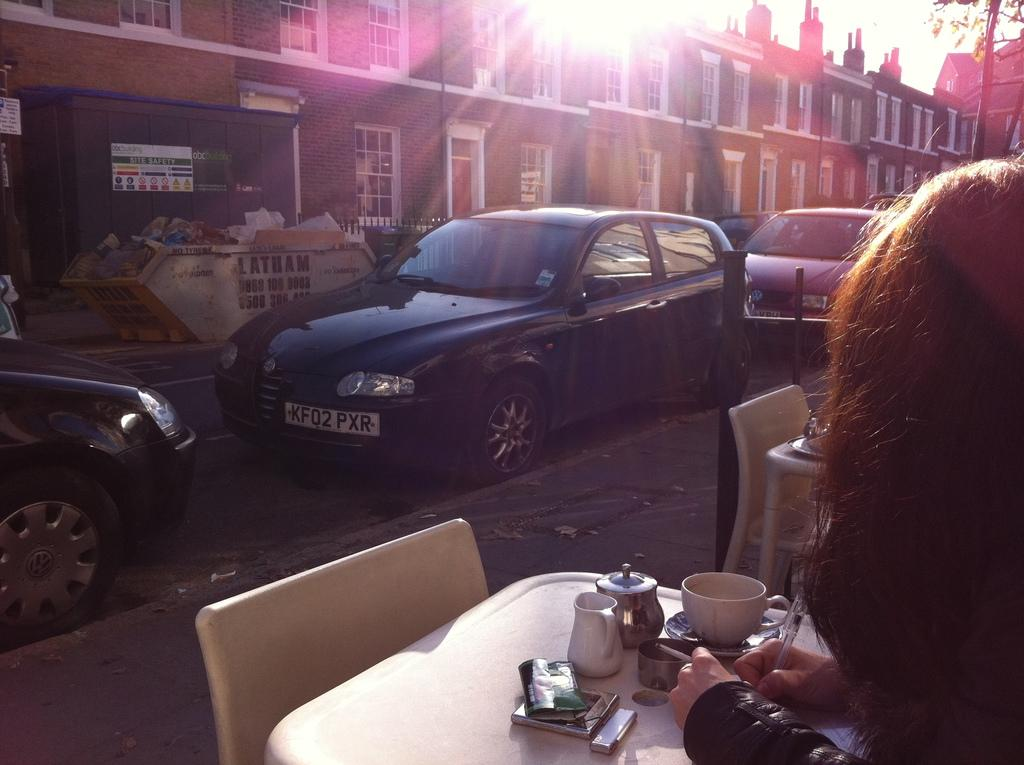What is the person in the image doing? The person is sitting in the image. What is the person holding in the image? The person is holding a pen. What can be seen in the background of the image? There are vehicles, the sky, a tree, and a building visible in the background of the image. How many mice are playing the game in the image? There are no mice or game present in the image. What is the person attempting to do in the image? The provided facts do not indicate any specific attempt or goal of the person in the image. 